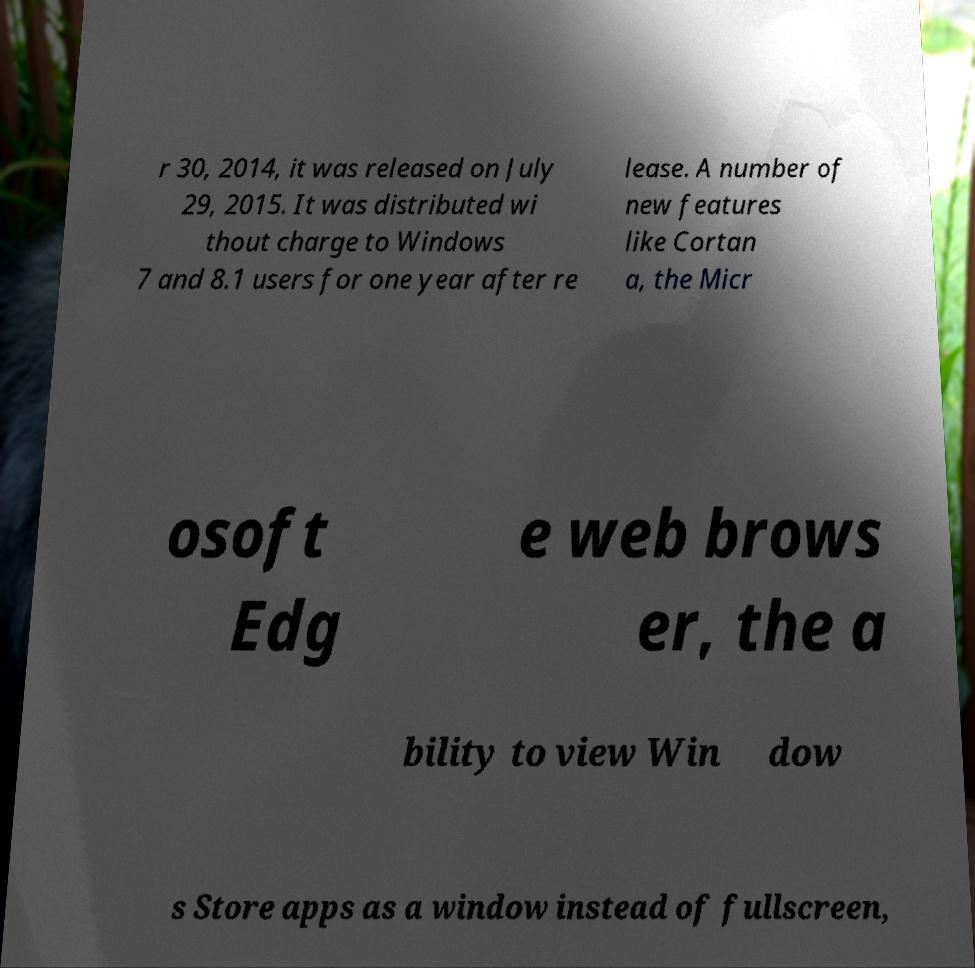There's text embedded in this image that I need extracted. Can you transcribe it verbatim? r 30, 2014, it was released on July 29, 2015. It was distributed wi thout charge to Windows 7 and 8.1 users for one year after re lease. A number of new features like Cortan a, the Micr osoft Edg e web brows er, the a bility to view Win dow s Store apps as a window instead of fullscreen, 